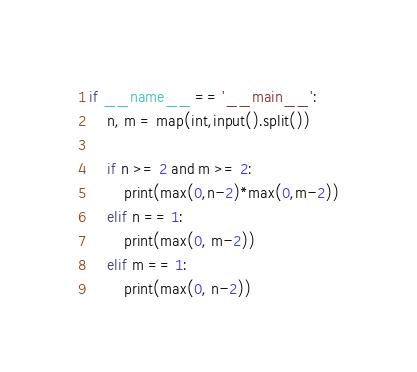<code> <loc_0><loc_0><loc_500><loc_500><_Python_>if __name__ == '__main__':
    n, m = map(int,input().split())

    if n >= 2 and m >= 2:
        print(max(0,n-2)*max(0,m-2))
    elif n == 1:
        print(max(0, m-2))
    elif m == 1:
        print(max(0, n-2))
</code> 